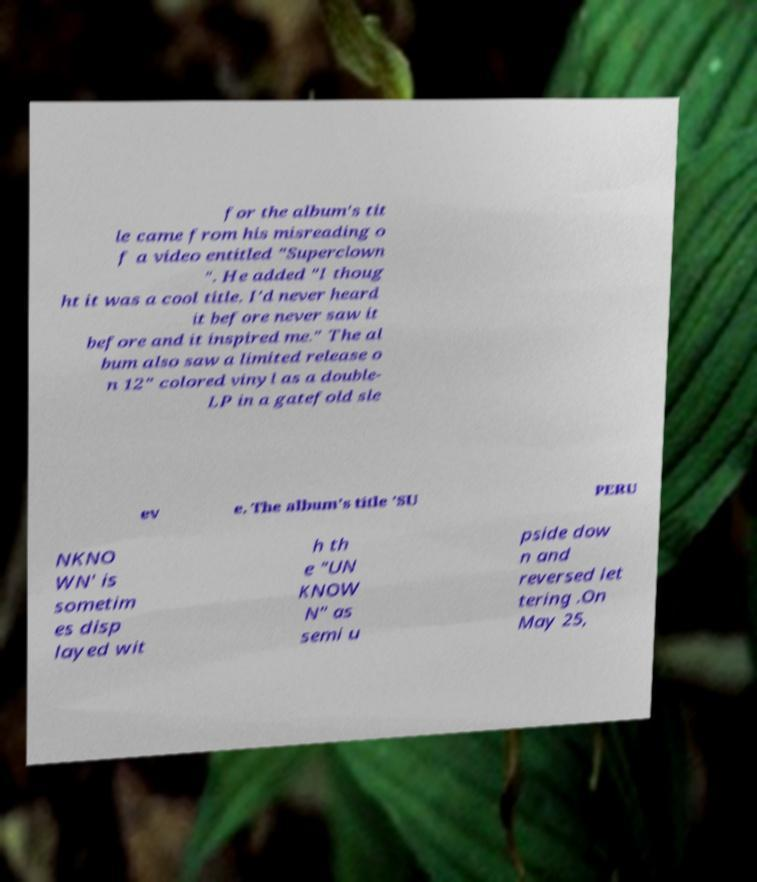What messages or text are displayed in this image? I need them in a readable, typed format. for the album's tit le came from his misreading o f a video entitled "Superclown ". He added "I thoug ht it was a cool title. I'd never heard it before never saw it before and it inspired me." The al bum also saw a limited release o n 12" colored vinyl as a double- LP in a gatefold sle ev e. The album's title 'SU PERU NKNO WN' is sometim es disp layed wit h th e "UN KNOW N" as semi u pside dow n and reversed let tering .On May 25, 